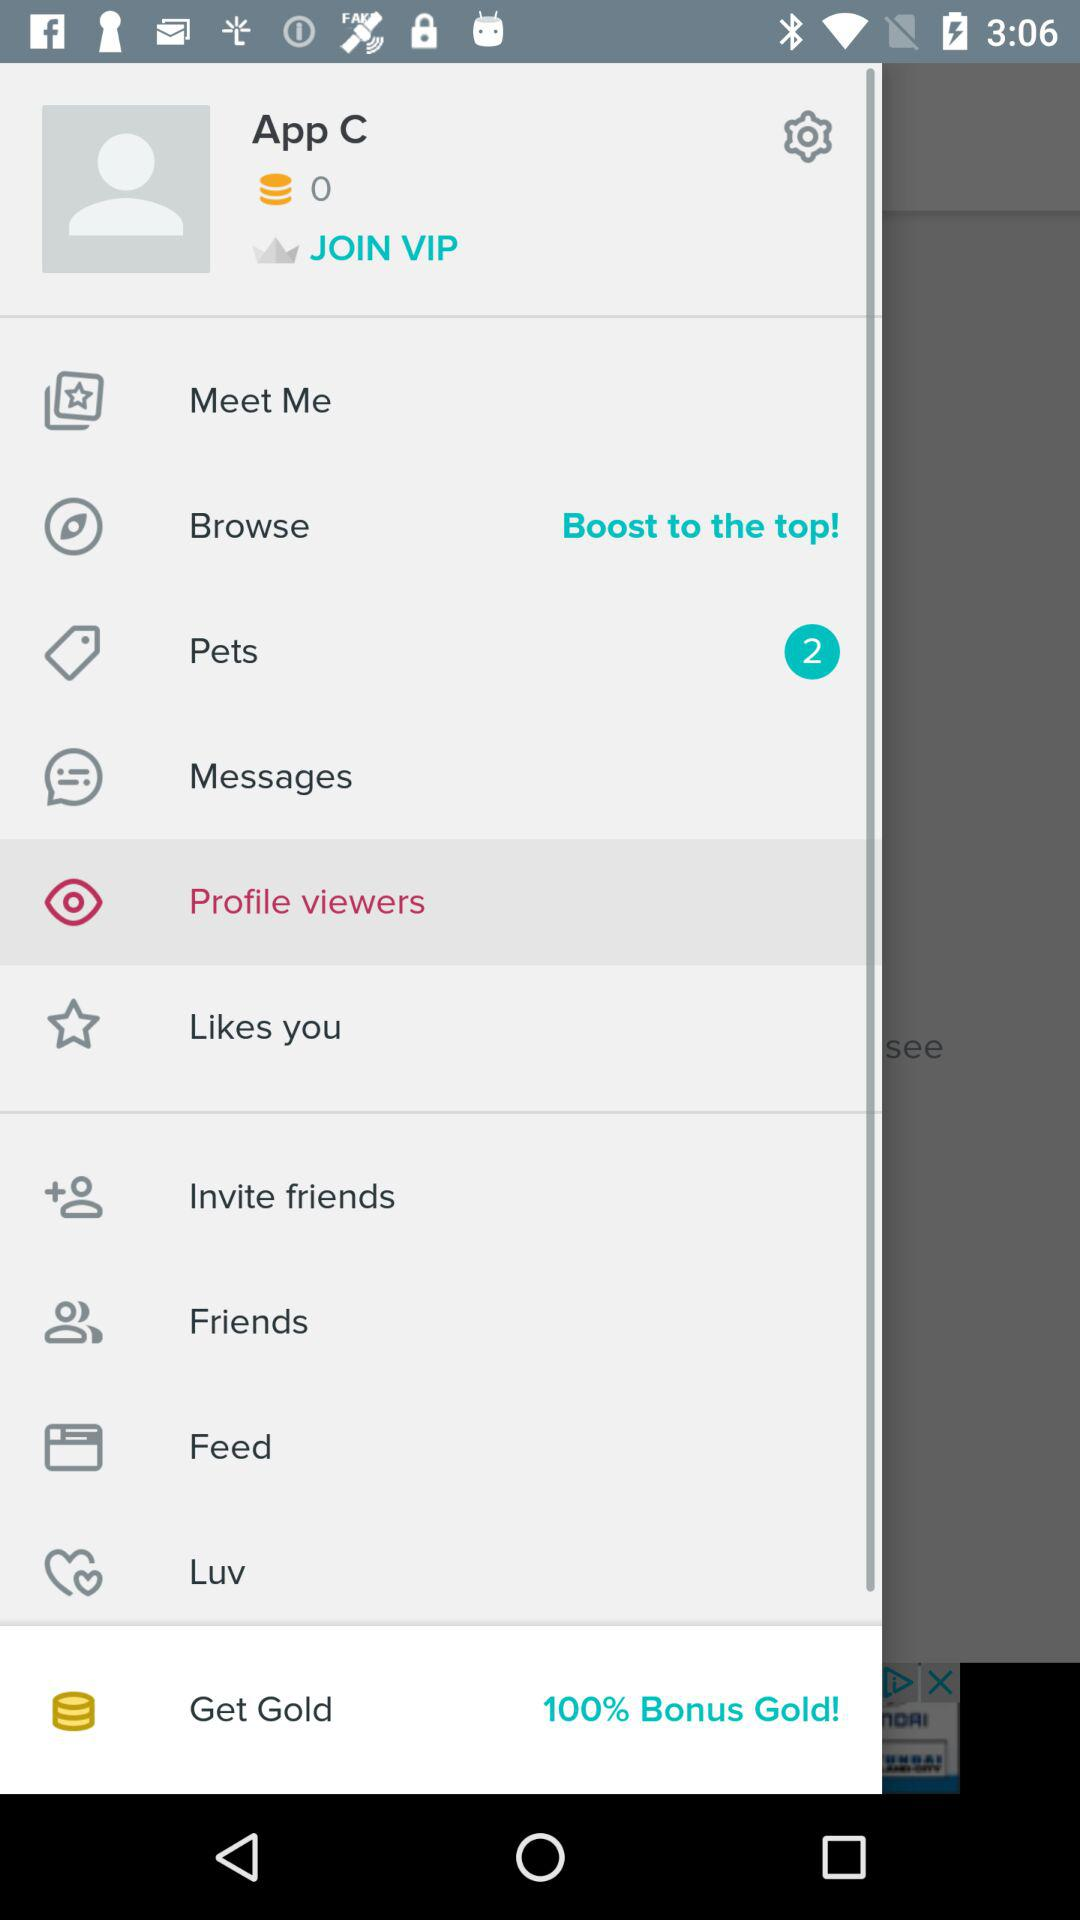How many unread notifications are there in "Pets"? There are 2 unread notifications in "Pets". 